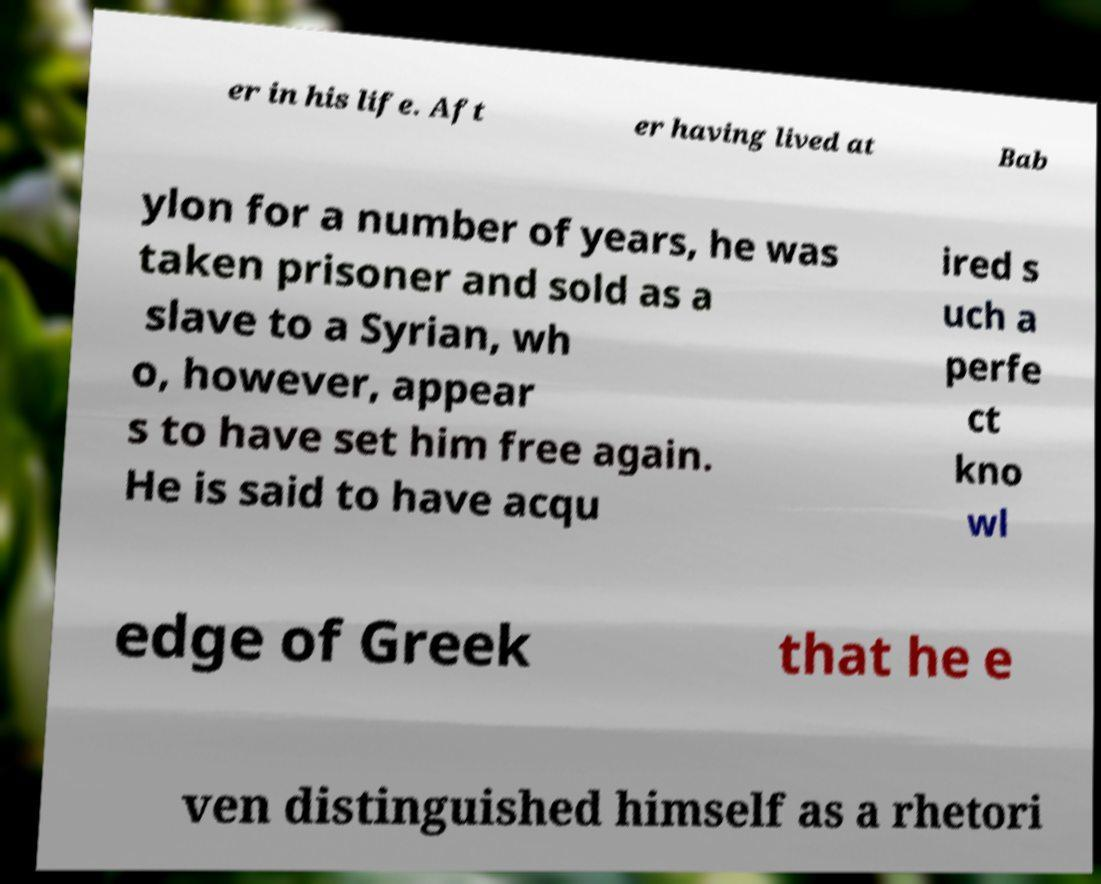Can you read and provide the text displayed in the image?This photo seems to have some interesting text. Can you extract and type it out for me? er in his life. Aft er having lived at Bab ylon for a number of years, he was taken prisoner and sold as a slave to a Syrian, wh o, however, appear s to have set him free again. He is said to have acqu ired s uch a perfe ct kno wl edge of Greek that he e ven distinguished himself as a rhetori 